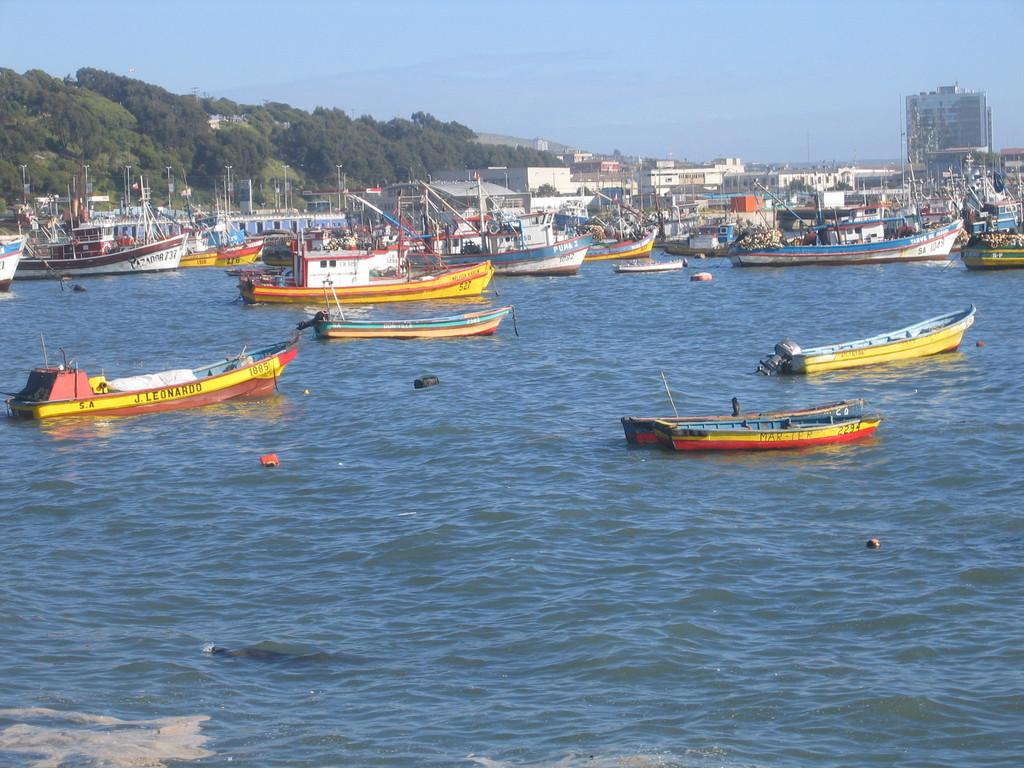What is happening in the center of the image? There are boats sailing in the center of the image. What is the boats sailing on? The boats are on water. What can be seen in the background of the image? There are ships, trees, and buildings in the background of the image. How many pickles are floating in the water next to the boats? There are no pickles present in the image; it features boats sailing on water. What type of birds can be seen flying over the trees in the background? There are no birds visible in the image; it only shows boats sailing on water, ships, trees, and buildings in the background. 